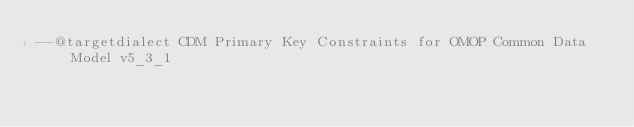<code> <loc_0><loc_0><loc_500><loc_500><_SQL_>--@targetdialect CDM Primary Key Constraints for OMOP Common Data Model v5_3_1
 </code> 